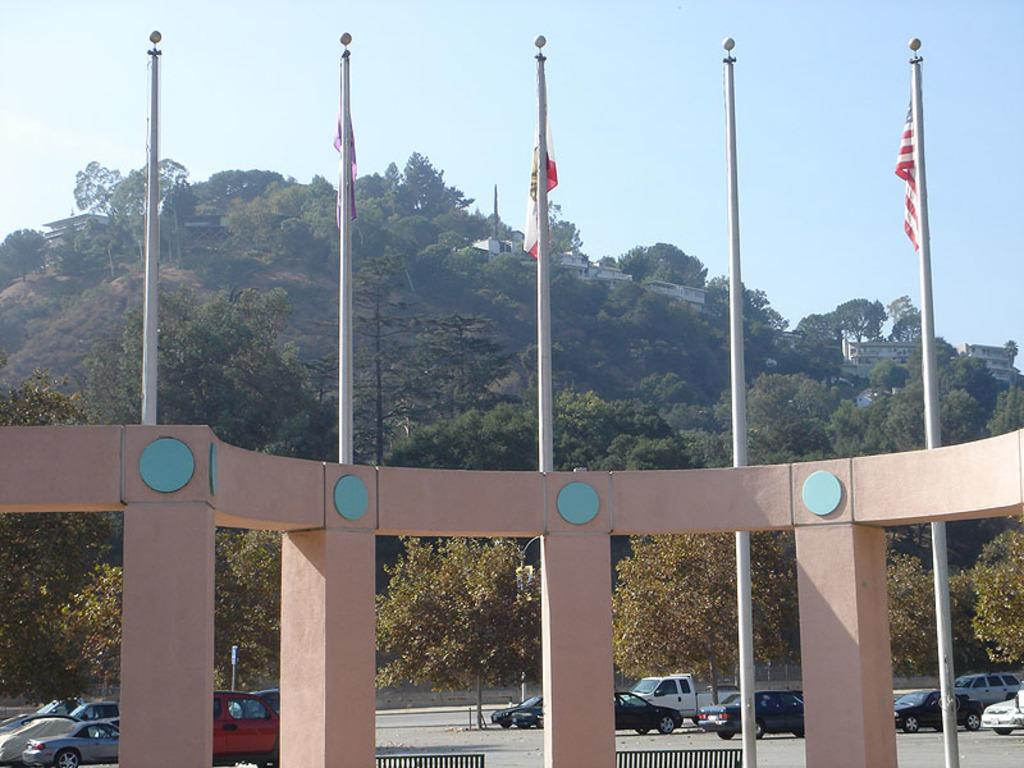What is the main subject in the foreground of the image? There is an architecture in the foreground of the image. What can be seen on the architecture? Flags are present on the architecture. What is happening in the background of the image? There are vehicles moving on the road in the background. What type of natural elements can be seen in the background? Trees are visible in the background. What else can be seen in the background besides trees? Buildings are present in the background. What is visible above the buildings and trees in the background? The sky is visible in the background. How many sisters are sitting on the yoke in the image? There are no sisters or yoke present in the image. 